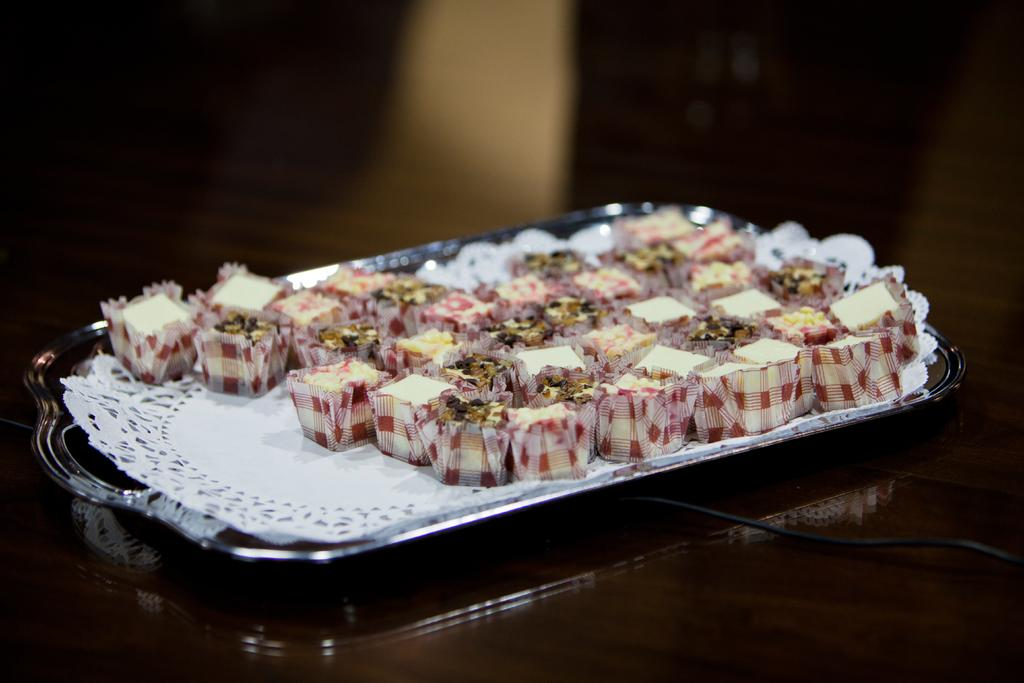What type of food is visible in the image? There are chocolates in the image. How are the chocolates arranged in the image? The chocolates are placed on a tray. Where is the tray with chocolates located? The tray is placed on a table. Can you describe the background of the image? The backdrop of the image is blurred. What type of anger can be seen in the image? There is no anger present in the image; it features chocolates on a tray. Can you describe the flight that is taking place in the image? There is no flight present in the image; it features chocolates on a tray. 